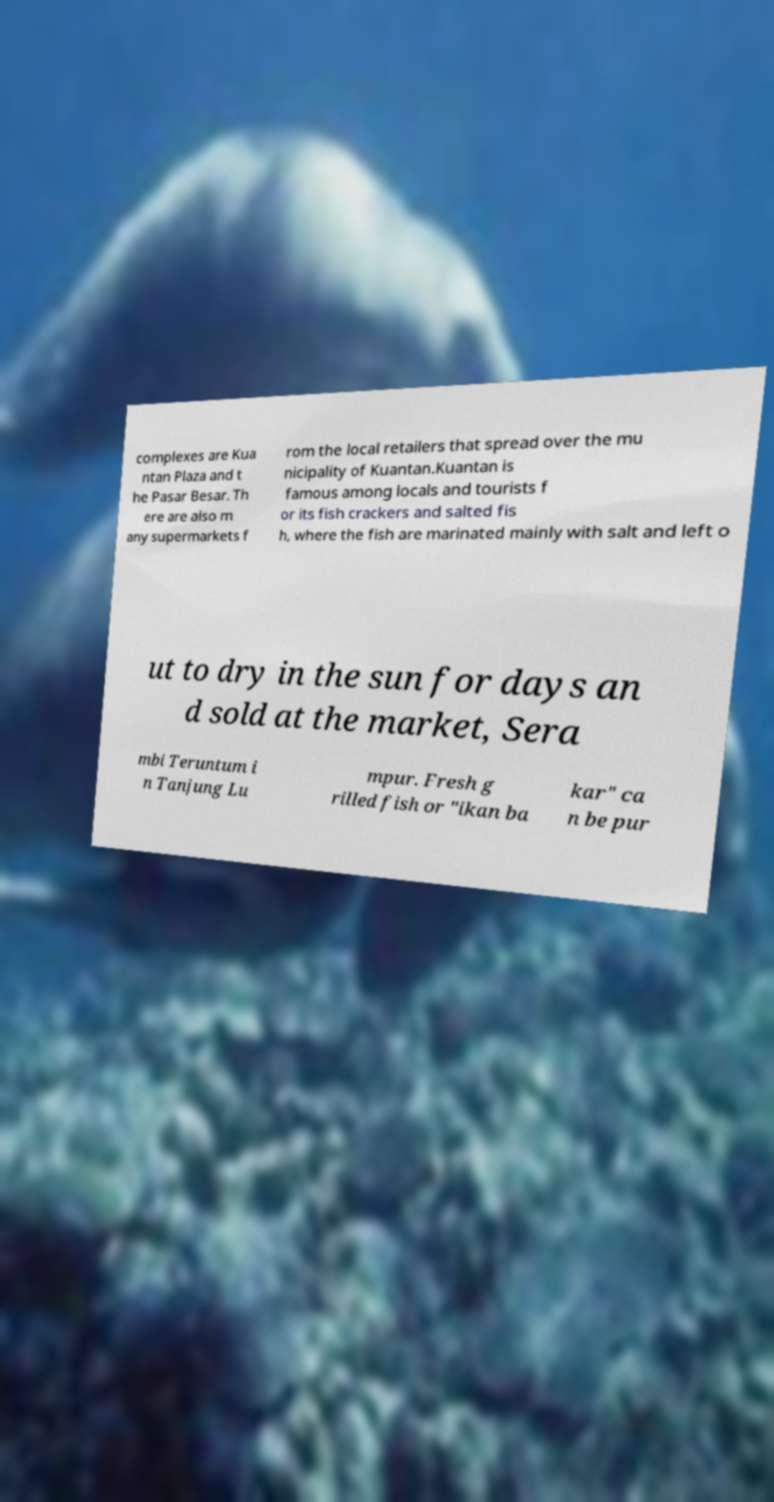I need the written content from this picture converted into text. Can you do that? complexes are Kua ntan Plaza and t he Pasar Besar. Th ere are also m any supermarkets f rom the local retailers that spread over the mu nicipality of Kuantan.Kuantan is famous among locals and tourists f or its fish crackers and salted fis h, where the fish are marinated mainly with salt and left o ut to dry in the sun for days an d sold at the market, Sera mbi Teruntum i n Tanjung Lu mpur. Fresh g rilled fish or "ikan ba kar" ca n be pur 